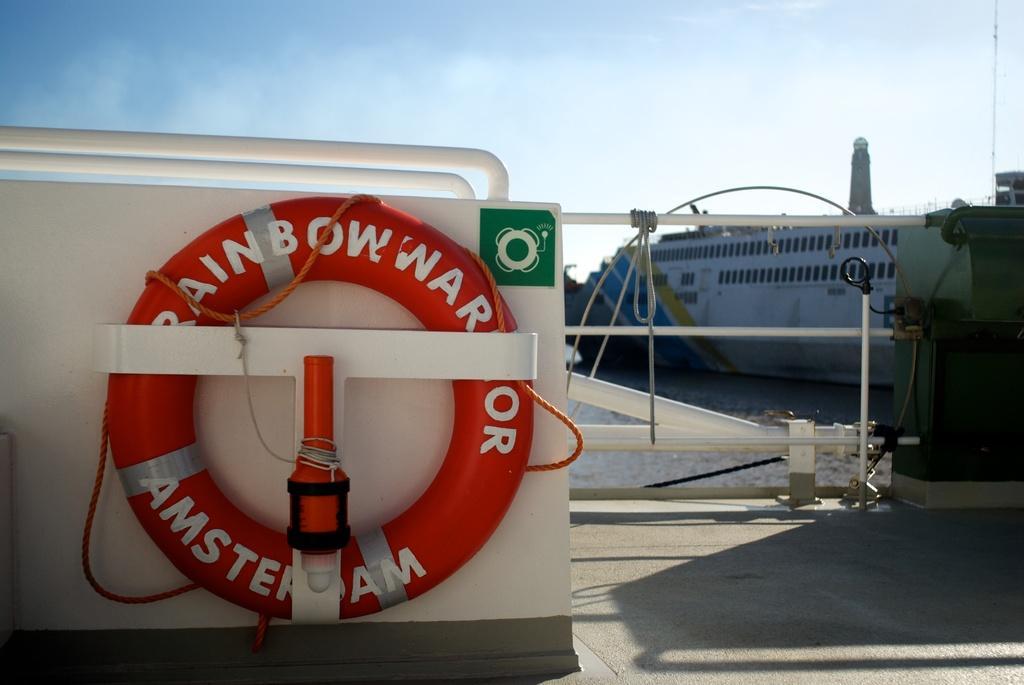Could you give a brief overview of what you see in this image? In this image we can see the red color inflatable is attached to the white color metal board. Background of the image, white color fencing and green color machine is there. Behind the fence, shop is there on the surface of water. 